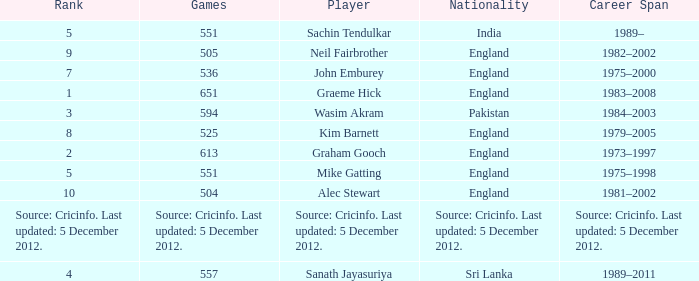What is the citizenship of the athlete who participated in 505 matches? England. 